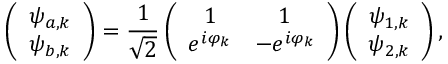<formula> <loc_0><loc_0><loc_500><loc_500>\left ( \begin{array} { c } { \psi _ { a , k } } \\ { \psi _ { b , k } } \end{array} \right ) = \frac { 1 } { \sqrt { 2 } } \left ( \begin{array} { c c } { 1 } & { 1 } \\ { e ^ { i \varphi _ { k } } } & { - e ^ { i \varphi _ { k } } } \end{array} \right ) \left ( \begin{array} { c } { \psi _ { 1 , k } } \\ { \psi _ { 2 , k } } \end{array} \right ) ,</formula> 